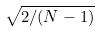Convert formula to latex. <formula><loc_0><loc_0><loc_500><loc_500>\sqrt { 2 / ( N - 1 ) }</formula> 